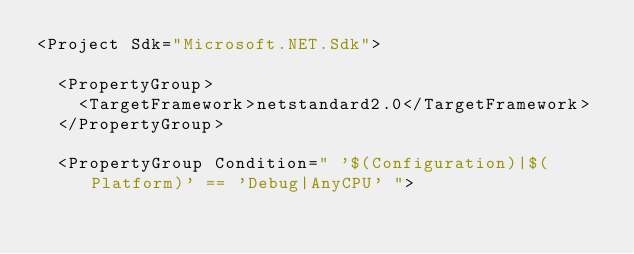<code> <loc_0><loc_0><loc_500><loc_500><_XML_><Project Sdk="Microsoft.NET.Sdk">

  <PropertyGroup>
    <TargetFramework>netstandard2.0</TargetFramework>
  </PropertyGroup>

  <PropertyGroup Condition=" '$(Configuration)|$(Platform)' == 'Debug|AnyCPU' "></code> 